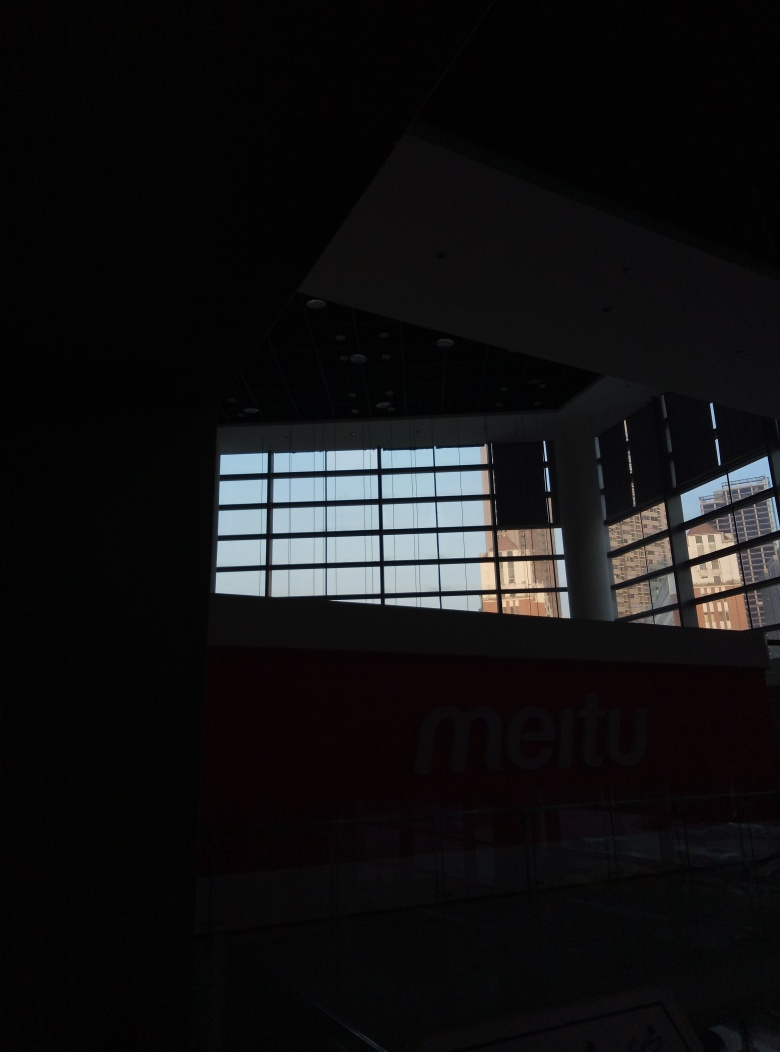Is it easy to identify the details in the main subject structure? Given the image provided, it is indeed challenging to identify details in the main subject structure due to insufficient lighting and the high contrast between the bright exterior seen through the windows and the much darker interior. This contrast makes it difficult to discern fine details, especially in the shadowed areas. Hence, the most appropriate answer from the given options would be D. No, it is difficult to identify the details. 